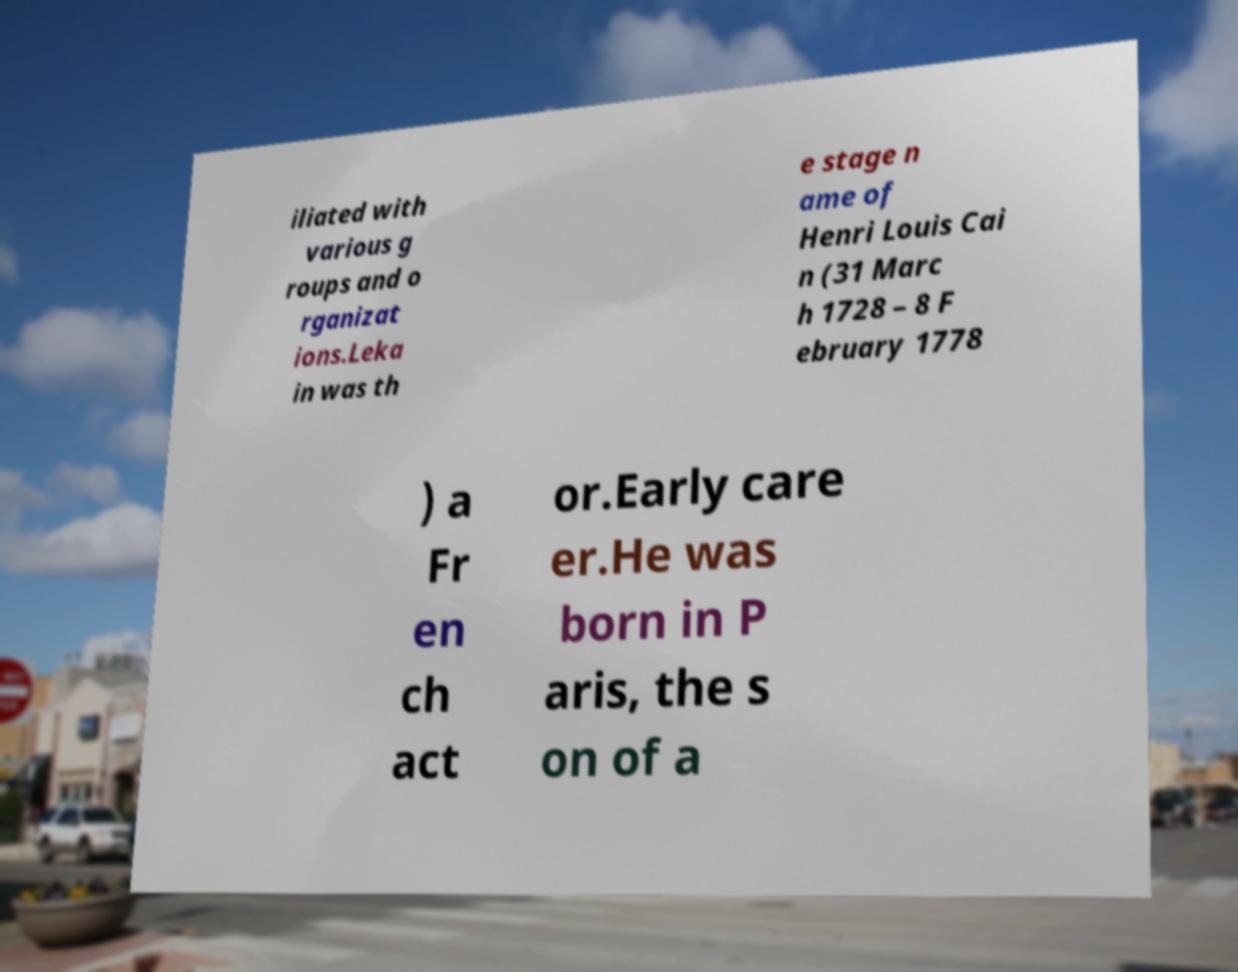Can you accurately transcribe the text from the provided image for me? iliated with various g roups and o rganizat ions.Leka in was th e stage n ame of Henri Louis Cai n (31 Marc h 1728 – 8 F ebruary 1778 ) a Fr en ch act or.Early care er.He was born in P aris, the s on of a 